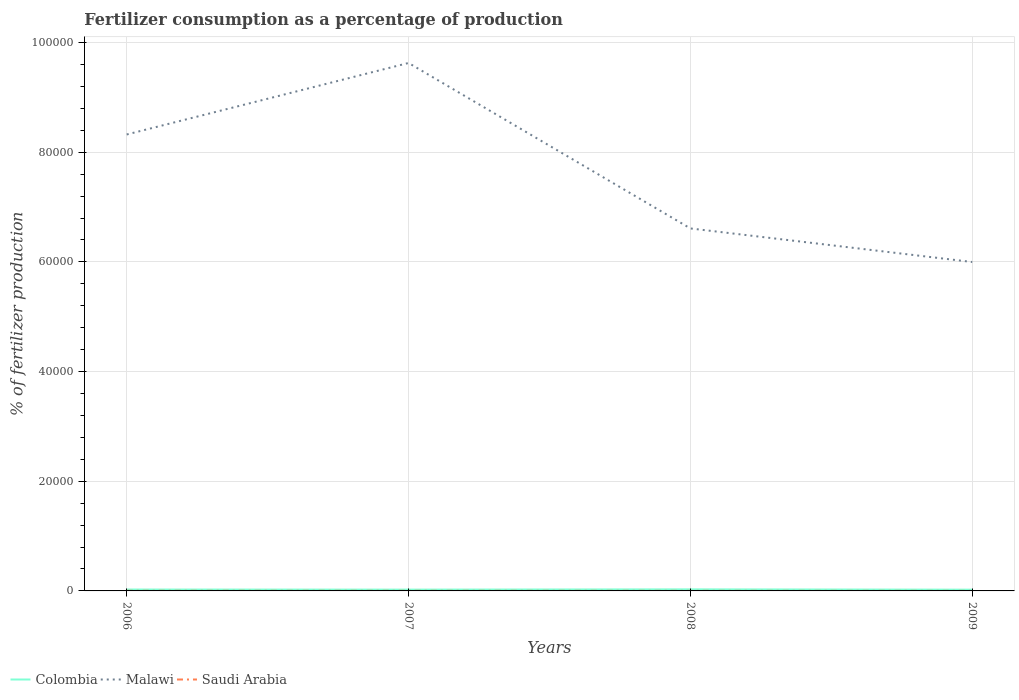Does the line corresponding to Saudi Arabia intersect with the line corresponding to Colombia?
Make the answer very short. No. Is the number of lines equal to the number of legend labels?
Offer a terse response. Yes. Across all years, what is the maximum percentage of fertilizers consumed in Colombia?
Keep it short and to the point. 226.96. What is the total percentage of fertilizers consumed in Colombia in the graph?
Keep it short and to the point. 58.23. What is the difference between the highest and the second highest percentage of fertilizers consumed in Malawi?
Your response must be concise. 3.63e+04. What is the difference between the highest and the lowest percentage of fertilizers consumed in Saudi Arabia?
Provide a short and direct response. 2. How many lines are there?
Make the answer very short. 3. What is the difference between two consecutive major ticks on the Y-axis?
Your answer should be compact. 2.00e+04. Does the graph contain any zero values?
Your response must be concise. No. How many legend labels are there?
Give a very brief answer. 3. What is the title of the graph?
Offer a very short reply. Fertilizer consumption as a percentage of production. What is the label or title of the Y-axis?
Offer a very short reply. % of fertilizer production. What is the % of fertilizer production in Colombia in 2006?
Provide a succinct answer. 252.07. What is the % of fertilizer production in Malawi in 2006?
Your answer should be compact. 8.32e+04. What is the % of fertilizer production in Saudi Arabia in 2006?
Provide a short and direct response. 21.6. What is the % of fertilizer production of Colombia in 2007?
Offer a very short reply. 236.31. What is the % of fertilizer production in Malawi in 2007?
Your answer should be compact. 9.63e+04. What is the % of fertilizer production of Saudi Arabia in 2007?
Your answer should be compact. 20.83. What is the % of fertilizer production in Colombia in 2008?
Make the answer very short. 285.19. What is the % of fertilizer production in Malawi in 2008?
Ensure brevity in your answer.  6.61e+04. What is the % of fertilizer production in Saudi Arabia in 2008?
Provide a succinct answer. 14.49. What is the % of fertilizer production of Colombia in 2009?
Make the answer very short. 226.96. What is the % of fertilizer production of Malawi in 2009?
Keep it short and to the point. 6.00e+04. What is the % of fertilizer production in Saudi Arabia in 2009?
Your answer should be compact. 8.81. Across all years, what is the maximum % of fertilizer production of Colombia?
Provide a short and direct response. 285.19. Across all years, what is the maximum % of fertilizer production of Malawi?
Offer a very short reply. 9.63e+04. Across all years, what is the maximum % of fertilizer production in Saudi Arabia?
Provide a succinct answer. 21.6. Across all years, what is the minimum % of fertilizer production in Colombia?
Offer a terse response. 226.96. Across all years, what is the minimum % of fertilizer production of Malawi?
Give a very brief answer. 6.00e+04. Across all years, what is the minimum % of fertilizer production in Saudi Arabia?
Give a very brief answer. 8.81. What is the total % of fertilizer production in Colombia in the graph?
Your answer should be very brief. 1000.53. What is the total % of fertilizer production of Malawi in the graph?
Your response must be concise. 3.06e+05. What is the total % of fertilizer production in Saudi Arabia in the graph?
Offer a terse response. 65.73. What is the difference between the % of fertilizer production of Colombia in 2006 and that in 2007?
Provide a short and direct response. 15.76. What is the difference between the % of fertilizer production of Malawi in 2006 and that in 2007?
Provide a short and direct response. -1.30e+04. What is the difference between the % of fertilizer production of Saudi Arabia in 2006 and that in 2007?
Keep it short and to the point. 0.77. What is the difference between the % of fertilizer production of Colombia in 2006 and that in 2008?
Provide a succinct answer. -33.12. What is the difference between the % of fertilizer production in Malawi in 2006 and that in 2008?
Provide a succinct answer. 1.71e+04. What is the difference between the % of fertilizer production of Saudi Arabia in 2006 and that in 2008?
Offer a very short reply. 7.11. What is the difference between the % of fertilizer production in Colombia in 2006 and that in 2009?
Offer a very short reply. 25.11. What is the difference between the % of fertilizer production in Malawi in 2006 and that in 2009?
Your answer should be compact. 2.33e+04. What is the difference between the % of fertilizer production in Saudi Arabia in 2006 and that in 2009?
Keep it short and to the point. 12.8. What is the difference between the % of fertilizer production of Colombia in 2007 and that in 2008?
Offer a terse response. -48.88. What is the difference between the % of fertilizer production in Malawi in 2007 and that in 2008?
Give a very brief answer. 3.02e+04. What is the difference between the % of fertilizer production in Saudi Arabia in 2007 and that in 2008?
Your response must be concise. 6.34. What is the difference between the % of fertilizer production of Colombia in 2007 and that in 2009?
Your answer should be very brief. 9.35. What is the difference between the % of fertilizer production in Malawi in 2007 and that in 2009?
Keep it short and to the point. 3.63e+04. What is the difference between the % of fertilizer production in Saudi Arabia in 2007 and that in 2009?
Keep it short and to the point. 12.03. What is the difference between the % of fertilizer production of Colombia in 2008 and that in 2009?
Make the answer very short. 58.23. What is the difference between the % of fertilizer production in Malawi in 2008 and that in 2009?
Give a very brief answer. 6122.77. What is the difference between the % of fertilizer production in Saudi Arabia in 2008 and that in 2009?
Your response must be concise. 5.69. What is the difference between the % of fertilizer production in Colombia in 2006 and the % of fertilizer production in Malawi in 2007?
Give a very brief answer. -9.60e+04. What is the difference between the % of fertilizer production of Colombia in 2006 and the % of fertilizer production of Saudi Arabia in 2007?
Ensure brevity in your answer.  231.24. What is the difference between the % of fertilizer production in Malawi in 2006 and the % of fertilizer production in Saudi Arabia in 2007?
Your answer should be very brief. 8.32e+04. What is the difference between the % of fertilizer production in Colombia in 2006 and the % of fertilizer production in Malawi in 2008?
Make the answer very short. -6.58e+04. What is the difference between the % of fertilizer production of Colombia in 2006 and the % of fertilizer production of Saudi Arabia in 2008?
Your answer should be compact. 237.57. What is the difference between the % of fertilizer production of Malawi in 2006 and the % of fertilizer production of Saudi Arabia in 2008?
Provide a succinct answer. 8.32e+04. What is the difference between the % of fertilizer production of Colombia in 2006 and the % of fertilizer production of Malawi in 2009?
Make the answer very short. -5.97e+04. What is the difference between the % of fertilizer production of Colombia in 2006 and the % of fertilizer production of Saudi Arabia in 2009?
Ensure brevity in your answer.  243.26. What is the difference between the % of fertilizer production in Malawi in 2006 and the % of fertilizer production in Saudi Arabia in 2009?
Ensure brevity in your answer.  8.32e+04. What is the difference between the % of fertilizer production of Colombia in 2007 and the % of fertilizer production of Malawi in 2008?
Your answer should be very brief. -6.59e+04. What is the difference between the % of fertilizer production in Colombia in 2007 and the % of fertilizer production in Saudi Arabia in 2008?
Your response must be concise. 221.82. What is the difference between the % of fertilizer production of Malawi in 2007 and the % of fertilizer production of Saudi Arabia in 2008?
Make the answer very short. 9.63e+04. What is the difference between the % of fertilizer production of Colombia in 2007 and the % of fertilizer production of Malawi in 2009?
Your answer should be compact. -5.97e+04. What is the difference between the % of fertilizer production of Colombia in 2007 and the % of fertilizer production of Saudi Arabia in 2009?
Keep it short and to the point. 227.5. What is the difference between the % of fertilizer production in Malawi in 2007 and the % of fertilizer production in Saudi Arabia in 2009?
Your answer should be compact. 9.63e+04. What is the difference between the % of fertilizer production of Colombia in 2008 and the % of fertilizer production of Malawi in 2009?
Offer a very short reply. -5.97e+04. What is the difference between the % of fertilizer production of Colombia in 2008 and the % of fertilizer production of Saudi Arabia in 2009?
Your answer should be compact. 276.39. What is the difference between the % of fertilizer production of Malawi in 2008 and the % of fertilizer production of Saudi Arabia in 2009?
Provide a succinct answer. 6.61e+04. What is the average % of fertilizer production of Colombia per year?
Make the answer very short. 250.13. What is the average % of fertilizer production in Malawi per year?
Provide a succinct answer. 7.64e+04. What is the average % of fertilizer production in Saudi Arabia per year?
Ensure brevity in your answer.  16.43. In the year 2006, what is the difference between the % of fertilizer production of Colombia and % of fertilizer production of Malawi?
Your response must be concise. -8.30e+04. In the year 2006, what is the difference between the % of fertilizer production of Colombia and % of fertilizer production of Saudi Arabia?
Your answer should be very brief. 230.47. In the year 2006, what is the difference between the % of fertilizer production of Malawi and % of fertilizer production of Saudi Arabia?
Keep it short and to the point. 8.32e+04. In the year 2007, what is the difference between the % of fertilizer production in Colombia and % of fertilizer production in Malawi?
Provide a short and direct response. -9.60e+04. In the year 2007, what is the difference between the % of fertilizer production in Colombia and % of fertilizer production in Saudi Arabia?
Your answer should be very brief. 215.48. In the year 2007, what is the difference between the % of fertilizer production in Malawi and % of fertilizer production in Saudi Arabia?
Ensure brevity in your answer.  9.63e+04. In the year 2008, what is the difference between the % of fertilizer production of Colombia and % of fertilizer production of Malawi?
Offer a very short reply. -6.58e+04. In the year 2008, what is the difference between the % of fertilizer production in Colombia and % of fertilizer production in Saudi Arabia?
Provide a short and direct response. 270.7. In the year 2008, what is the difference between the % of fertilizer production in Malawi and % of fertilizer production in Saudi Arabia?
Your answer should be very brief. 6.61e+04. In the year 2009, what is the difference between the % of fertilizer production in Colombia and % of fertilizer production in Malawi?
Keep it short and to the point. -5.98e+04. In the year 2009, what is the difference between the % of fertilizer production in Colombia and % of fertilizer production in Saudi Arabia?
Ensure brevity in your answer.  218.16. In the year 2009, what is the difference between the % of fertilizer production in Malawi and % of fertilizer production in Saudi Arabia?
Make the answer very short. 6.00e+04. What is the ratio of the % of fertilizer production in Colombia in 2006 to that in 2007?
Ensure brevity in your answer.  1.07. What is the ratio of the % of fertilizer production in Malawi in 2006 to that in 2007?
Provide a succinct answer. 0.86. What is the ratio of the % of fertilizer production of Saudi Arabia in 2006 to that in 2007?
Ensure brevity in your answer.  1.04. What is the ratio of the % of fertilizer production in Colombia in 2006 to that in 2008?
Offer a terse response. 0.88. What is the ratio of the % of fertilizer production of Malawi in 2006 to that in 2008?
Keep it short and to the point. 1.26. What is the ratio of the % of fertilizer production of Saudi Arabia in 2006 to that in 2008?
Your answer should be very brief. 1.49. What is the ratio of the % of fertilizer production of Colombia in 2006 to that in 2009?
Make the answer very short. 1.11. What is the ratio of the % of fertilizer production in Malawi in 2006 to that in 2009?
Your answer should be very brief. 1.39. What is the ratio of the % of fertilizer production of Saudi Arabia in 2006 to that in 2009?
Provide a short and direct response. 2.45. What is the ratio of the % of fertilizer production of Colombia in 2007 to that in 2008?
Your answer should be very brief. 0.83. What is the ratio of the % of fertilizer production of Malawi in 2007 to that in 2008?
Give a very brief answer. 1.46. What is the ratio of the % of fertilizer production of Saudi Arabia in 2007 to that in 2008?
Ensure brevity in your answer.  1.44. What is the ratio of the % of fertilizer production in Colombia in 2007 to that in 2009?
Offer a terse response. 1.04. What is the ratio of the % of fertilizer production of Malawi in 2007 to that in 2009?
Your answer should be very brief. 1.61. What is the ratio of the % of fertilizer production in Saudi Arabia in 2007 to that in 2009?
Your response must be concise. 2.37. What is the ratio of the % of fertilizer production in Colombia in 2008 to that in 2009?
Keep it short and to the point. 1.26. What is the ratio of the % of fertilizer production of Malawi in 2008 to that in 2009?
Your answer should be very brief. 1.1. What is the ratio of the % of fertilizer production in Saudi Arabia in 2008 to that in 2009?
Keep it short and to the point. 1.65. What is the difference between the highest and the second highest % of fertilizer production in Colombia?
Your answer should be very brief. 33.12. What is the difference between the highest and the second highest % of fertilizer production of Malawi?
Offer a terse response. 1.30e+04. What is the difference between the highest and the second highest % of fertilizer production of Saudi Arabia?
Provide a short and direct response. 0.77. What is the difference between the highest and the lowest % of fertilizer production in Colombia?
Offer a terse response. 58.23. What is the difference between the highest and the lowest % of fertilizer production in Malawi?
Keep it short and to the point. 3.63e+04. What is the difference between the highest and the lowest % of fertilizer production in Saudi Arabia?
Keep it short and to the point. 12.8. 